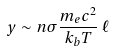<formula> <loc_0><loc_0><loc_500><loc_500>y \sim n \sigma \frac { m _ { e } c ^ { 2 } } { k _ { b } T } \, \ell</formula> 